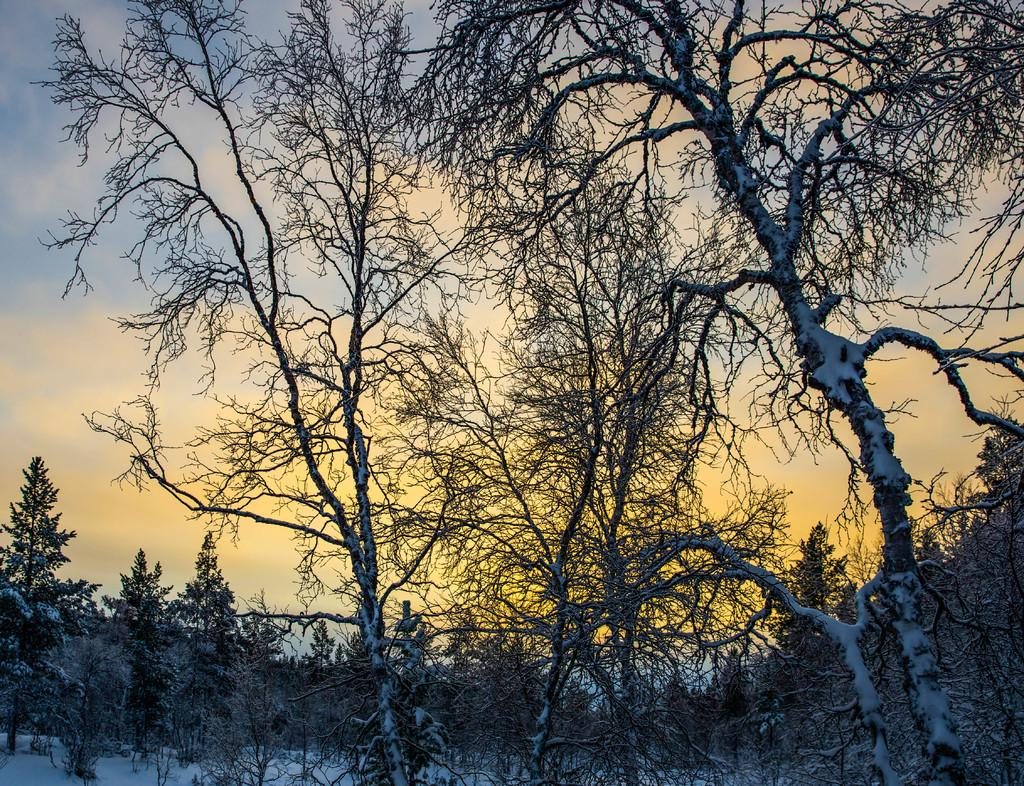What type of vegetation can be seen in the image? There are trees in the image. What is the weather like in the image? There is snow visible in the image, which suggests a cold or snowy weather. What is visible in the sky in the image? The sky is visible in the image. Where is the crib located in the image? There is no crib present in the image. What type of books can be seen in the library in the image? There is no library present in the image. 